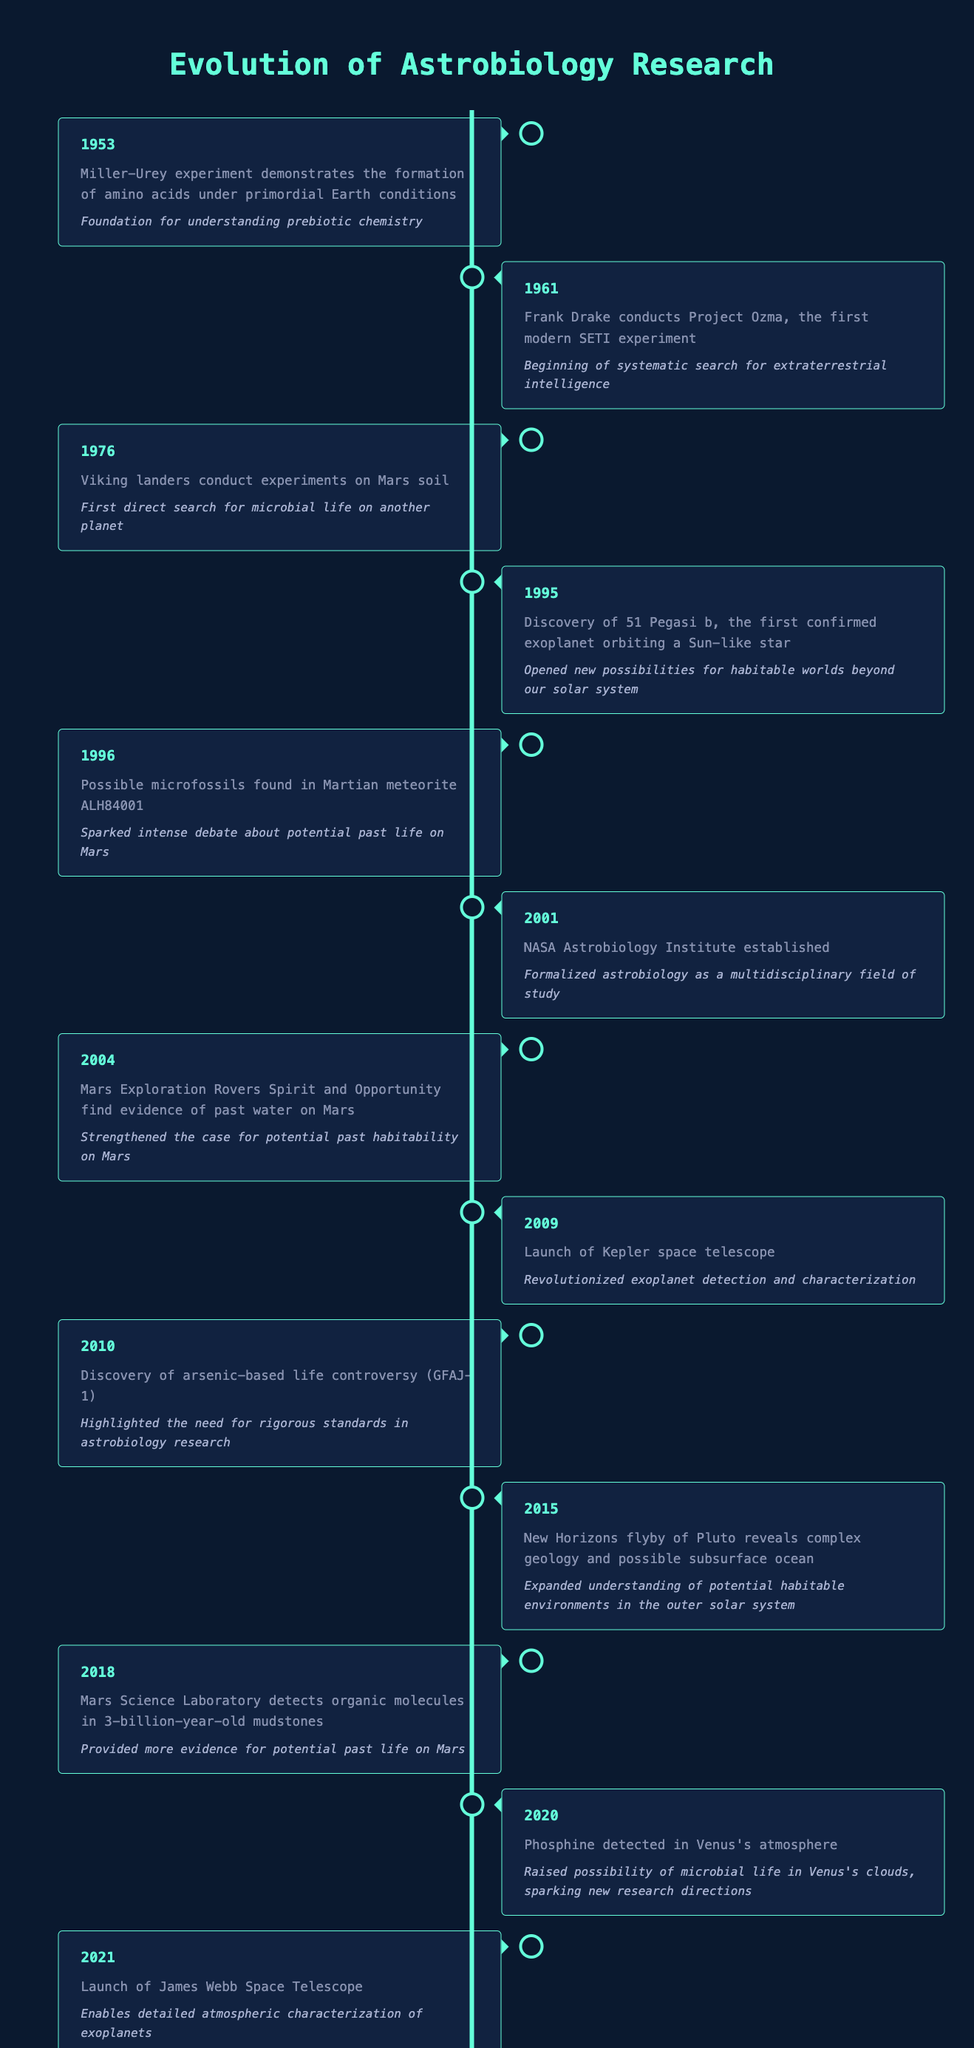What year did the Miller-Urey experiment take place? The table lists the event "Miller-Urey experiment demonstrates the formation of amino acids under primordial Earth conditions" in the year 1953. Hence, the year of this event is directly stated in the table.
Answer: 1953 Which milestone event occurred in 1961? The table indicates that "Frank Drake conducts Project Ozma, the first modern SETI experiment" occurred in 1961. Thus, referring back to the table, this is the event corresponding to that year.
Answer: Frank Drake conducts Project Ozma, the first modern SETI experiment Did the Viking landers conduct experiments on Mars soil before or after the discovery of 51 Pegasi b? The Viking landers conducted experiments in 1976, while the discovery of 51 Pegasi b happened in 1995. Since 1976 is earlier than 1995, we conclude that the Viking landers conducted their experiments before the latter discovery.
Answer: Before What is the significance of the Mars Exploration Rovers' findings in 2004? According to the timeline, the significance of findings from the Mars Exploration Rovers Spirit and Opportunity in 2004 is that they "strengthened the case for potential past habitability on Mars." Therefore, this is the significance of their discoveries.
Answer: Strengthened the case for potential past habitability on Mars What is the range of years during which possible life detection events occurred? The table indicates events related to possible life detection in two years: in 1996 with the possible microfossils in Martian meteorite ALH84001, and in 2018 with organic molecules detected in Mars mudstones. Therefore, the range of years is from 1996 to 2018.
Answer: 1996 to 2018 If the first event establishes a foundation for prebiotic chemistry, how many years later was NASA's Astrobiology Institute established? The first event in the timeline is from 1953, and the NASA Astrobiology Institute was established in 2001. To find the difference in years, we subtract 1953 from 2001, which gives us 48 years. Thus, the Institute was established 48 years after the first event.
Answer: 48 years Was the detection of phosphine in Venus's atmosphere noticed before the launch of the James Webb Space Telescope? The table states that phosphine was detected in 2020 and the James Webb Space Telescope was launched in 2021. Since 2020 is before 2021, we can confirm that the detection occurred prior to the launch.
Answer: Yes What event occurred in 2010 and why was it significant? According to the timeline, in 2010 "Discovery of arsenic-based life controversy (GFAJ-1)" occurred, and it was significant because it "highlighted the need for rigorous standards in astrobiology research." Therefore, both the event and its significance are extracted clearly from the table.
Answer: Discovery of arsenic-based life controversy (GFAJ-1); highlighted the need for rigorous standards in astrobiology research What was the most recent event listed in the table related to astrobiology? The most recent event according to the table is from 2021, where it states "Launch of James Webb Space Telescope." Since this is the last entry in the timeline, it marks the most recent event related to astrobiology research.
Answer: Launch of James Webb Space Telescope 